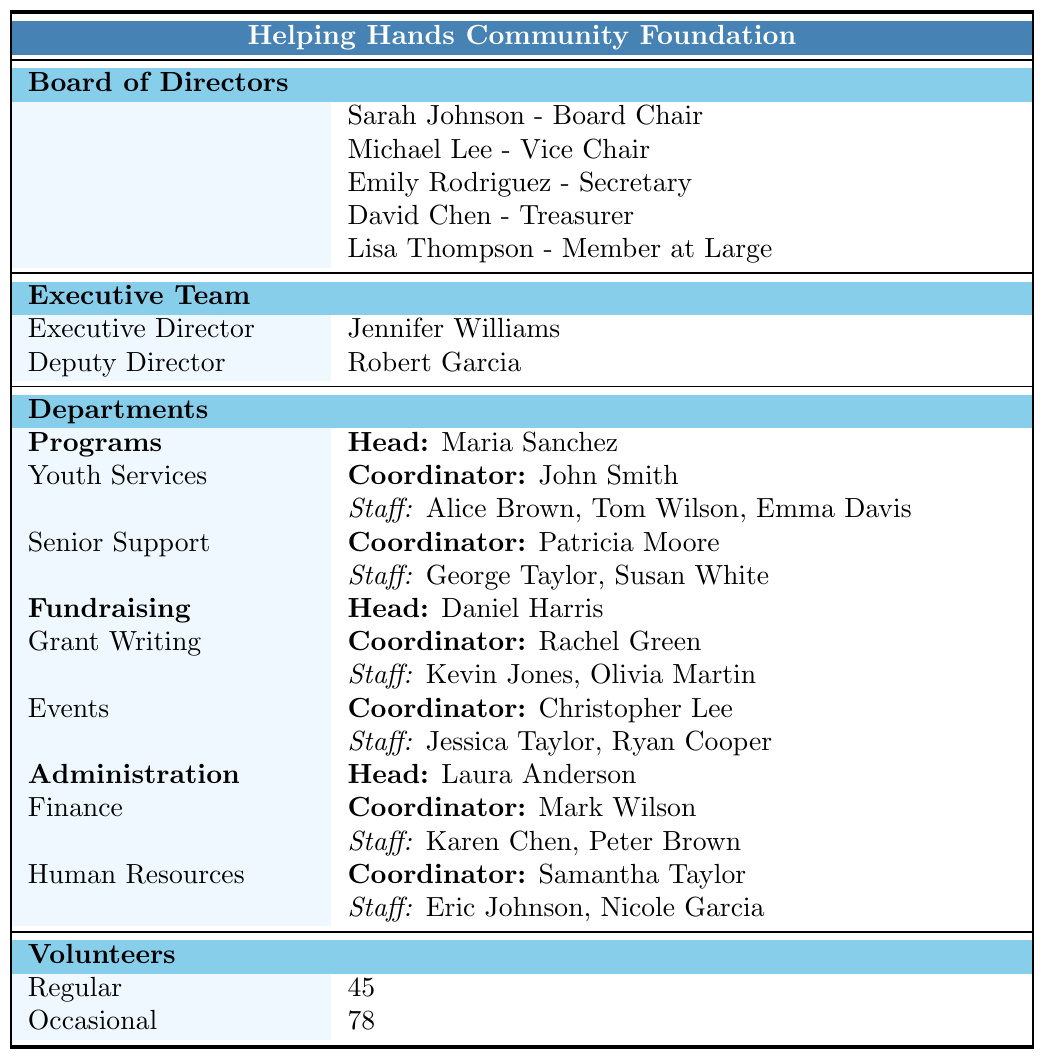What is the name of the Board Chair for Helping Hands Community Foundation? The Board Chair's name is mentioned in the "Board of Directors" section of the table, which lists Sarah Johnson as the Board Chair.
Answer: Sarah Johnson Who coordinates the Youth Services team? In the "Programs" department, under the "Youth Services" team, it states that John Smith is the Coordinator.
Answer: John Smith How many volunteers are classified as Regular? The table provides a "Volunteers" section where it states that there are 45 Regular volunteers.
Answer: 45 Which department is headed by Laura Anderson? By looking at the "Departments" section, it shows that the "Administration" department is headed by Laura Anderson.
Answer: Administration How many staff members are in the Senior Support team? The "Senior Support" team has two staff members listed: George Taylor and Susan White. Therefore, we count them which gives us a total of 2 staff members.
Answer: 2 Does the Executive Director have a Deputy Director? The "Executive Team" section indicates the presence of a Deputy Director, confirming that yes, the Executive Director does have a Deputy Director.
Answer: Yes What is the total number of staff in the Finance and Human Resources teams combined? The "Finance" team lists 2 staff members (Karen Chen and Peter Brown) and the "Human Resources" team also has 2 staff members (Eric Johnson and Nicole Garcia). Adding these together gives us 2 + 2 = 4 staff members total.
Answer: 4 Is there a program dedicated to Senior Support? The "Programs" section specifically includes a team called "Senior Support," confirming that there is indeed a program dedicated to it.
Answer: Yes What is the Coordinator's name for the Grant Writing team? Under the "Fundraising" department, the "Grant Writing" team lists Rachel Green as the Coordinator.
Answer: Rachel Green How many teams are there under the Fundraising department? The "Fundraising" department has two teams listed, which are "Grant Writing" and "Events," making the total count of teams 2.
Answer: 2 What is the relationship between the Executive Director and the Deputy Director? In the "Executive Team" section, it is indicated that they both serve under the same leadership team with the Executive Director being Jennifer Williams and the Deputy Director being Robert Garcia. Hence, their relationship is one of hierarchy in the organizational structure.
Answer: Hierarchical Which department has more staff members: Programs or Administration? In the "Programs" department, there are a total of 5 staff members (3 from Youth Services and 2 from Senior Support), while in the "Administration" department, there are also 4 staff members (2 from Finance and 2 from Human Resources). Comparing the two shows Programs has more staff members, totaling 5 compared to Administration's 4.
Answer: Programs What percentage of the total volunteers are classified as Occasional? To determine the percentage, we first need the total number of volunteers, which combines Regular (45) and Occasional (78) volunteers, totaling 123. The formula for percentage is (Occasional / Total Volunteers) * 100, which is (78 / 123) * 100 ≈ 63.41%. Thus, it means that around 63% of the volunteers are classified as Occasional.
Answer: 63% 